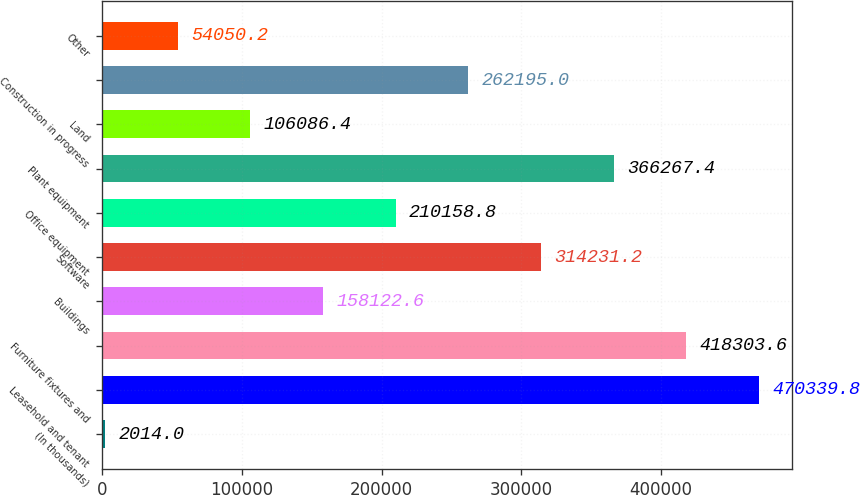<chart> <loc_0><loc_0><loc_500><loc_500><bar_chart><fcel>(In thousands)<fcel>Leasehold and tenant<fcel>Furniture fixtures and<fcel>Buildings<fcel>Software<fcel>Office equipment<fcel>Plant equipment<fcel>Land<fcel>Construction in progress<fcel>Other<nl><fcel>2014<fcel>470340<fcel>418304<fcel>158123<fcel>314231<fcel>210159<fcel>366267<fcel>106086<fcel>262195<fcel>54050.2<nl></chart> 